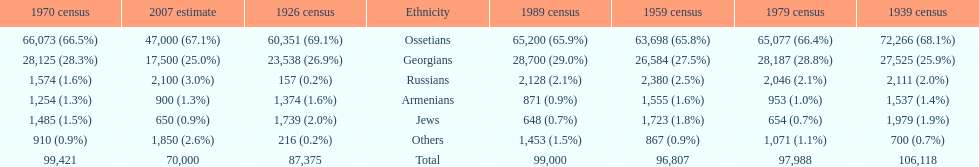How many russians lived in south ossetia in 1970? 1,574. 